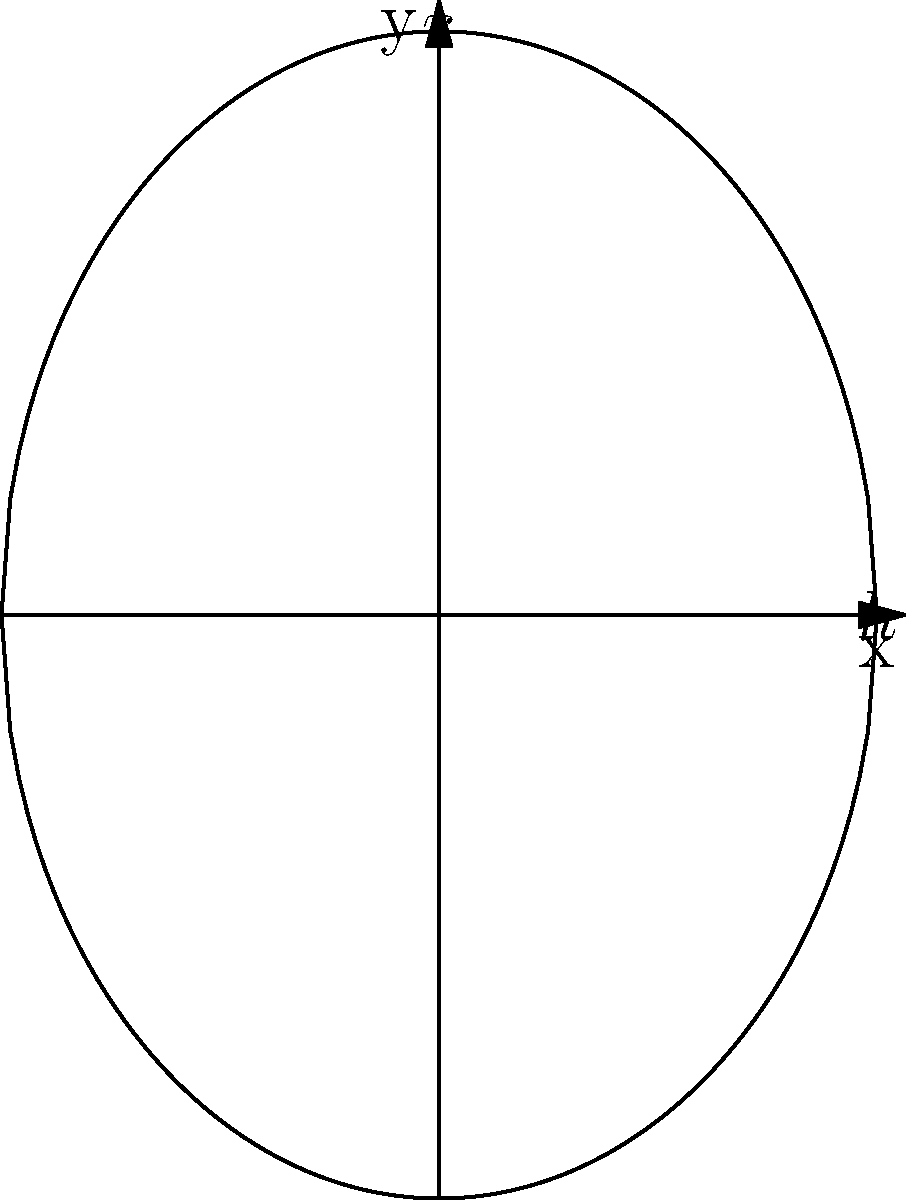As a sports bar owner, you're considering upgrading your beer keg storage to compete with food trucks during big games. You want to maximize volume while maintaining a sleek design. A new keg shape is proposed: a solid formed by rotating the region bounded by $y = \pm 4\sqrt{1-\frac{x^2}{9}}$ and the y-axis about the y-axis. Calculate the volume of this keg in cubic inches, rounded to the nearest whole number. Let's approach this step-by-step:

1) The curve given is $y = \pm 4\sqrt{1-\frac{x^2}{9}}$. This forms an ellipse with semi-major axis 4 on the y-axis and semi-minor axis 3 on the x-axis.

2) To find the volume, we'll use the washer method of integration. The volume is given by:

   $$V = \pi \int_a^b [R(y)^2 - r(y)^2] dy$$

   where $R(y)$ is the outer radius and $r(y)$ is the inner radius (0 in this case).

3) We need to express $x$ in terms of $y$:

   $$y = 4\sqrt{1-\frac{x^2}{9}} \implies \frac{y^2}{16} = 1-\frac{x^2}{9} \implies x^2 = 9(1-\frac{y^2}{16})$$

   $$x = 3\sqrt{1-\frac{y^2}{16}}$$

4) Now we can set up our integral:

   $$V = \pi \int_{-4}^4 [9(1-\frac{y^2}{16})] dy$$

5) Simplify:

   $$V = 9\pi \int_{-4}^4 (1-\frac{y^2}{16}) dy$$

6) Integrate:

   $$V = 9\pi [y - \frac{y^3}{48}]_{-4}^4$$

7) Evaluate:

   $$V = 9\pi [(4 - \frac{64}{48}) - (-4 - \frac{-64}{48})]$$
   $$V = 9\pi [4 - \frac{4}{3} + 4 + \frac{4}{3}]$$
   $$V = 9\pi [8] = 72\pi$$

8) Calculate and round to the nearest whole number:

   $$V \approx 226.19 \approx 226 \text{ cubic inches}$$
Answer: 226 cubic inches 